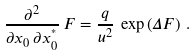<formula> <loc_0><loc_0><loc_500><loc_500>\frac { \partial ^ { 2 } } { \partial x _ { 0 } \, \partial x ^ { ^ { * } } _ { 0 } } \, F = \frac { q } { u ^ { 2 } } \, \exp \left ( \Delta F \right ) \, .</formula> 